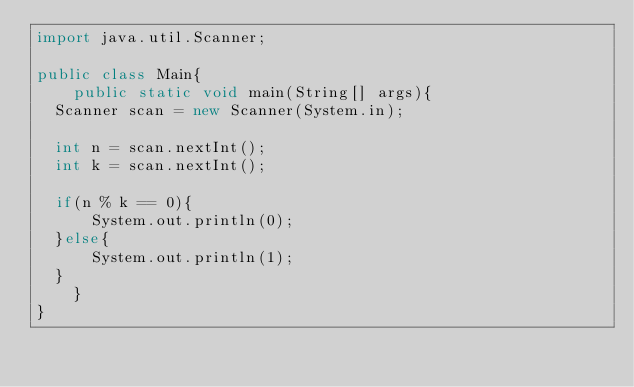<code> <loc_0><loc_0><loc_500><loc_500><_Java_>import java.util.Scanner;

public class Main{
    public static void main(String[] args){
	Scanner scan = new Scanner(System.in);

	int n = scan.nextInt();
	int k = scan.nextInt();

	if(n % k == 0){
	    System.out.println(0);
	}else{
	    System.out.println(1);
	}
    }
}
	    
</code> 